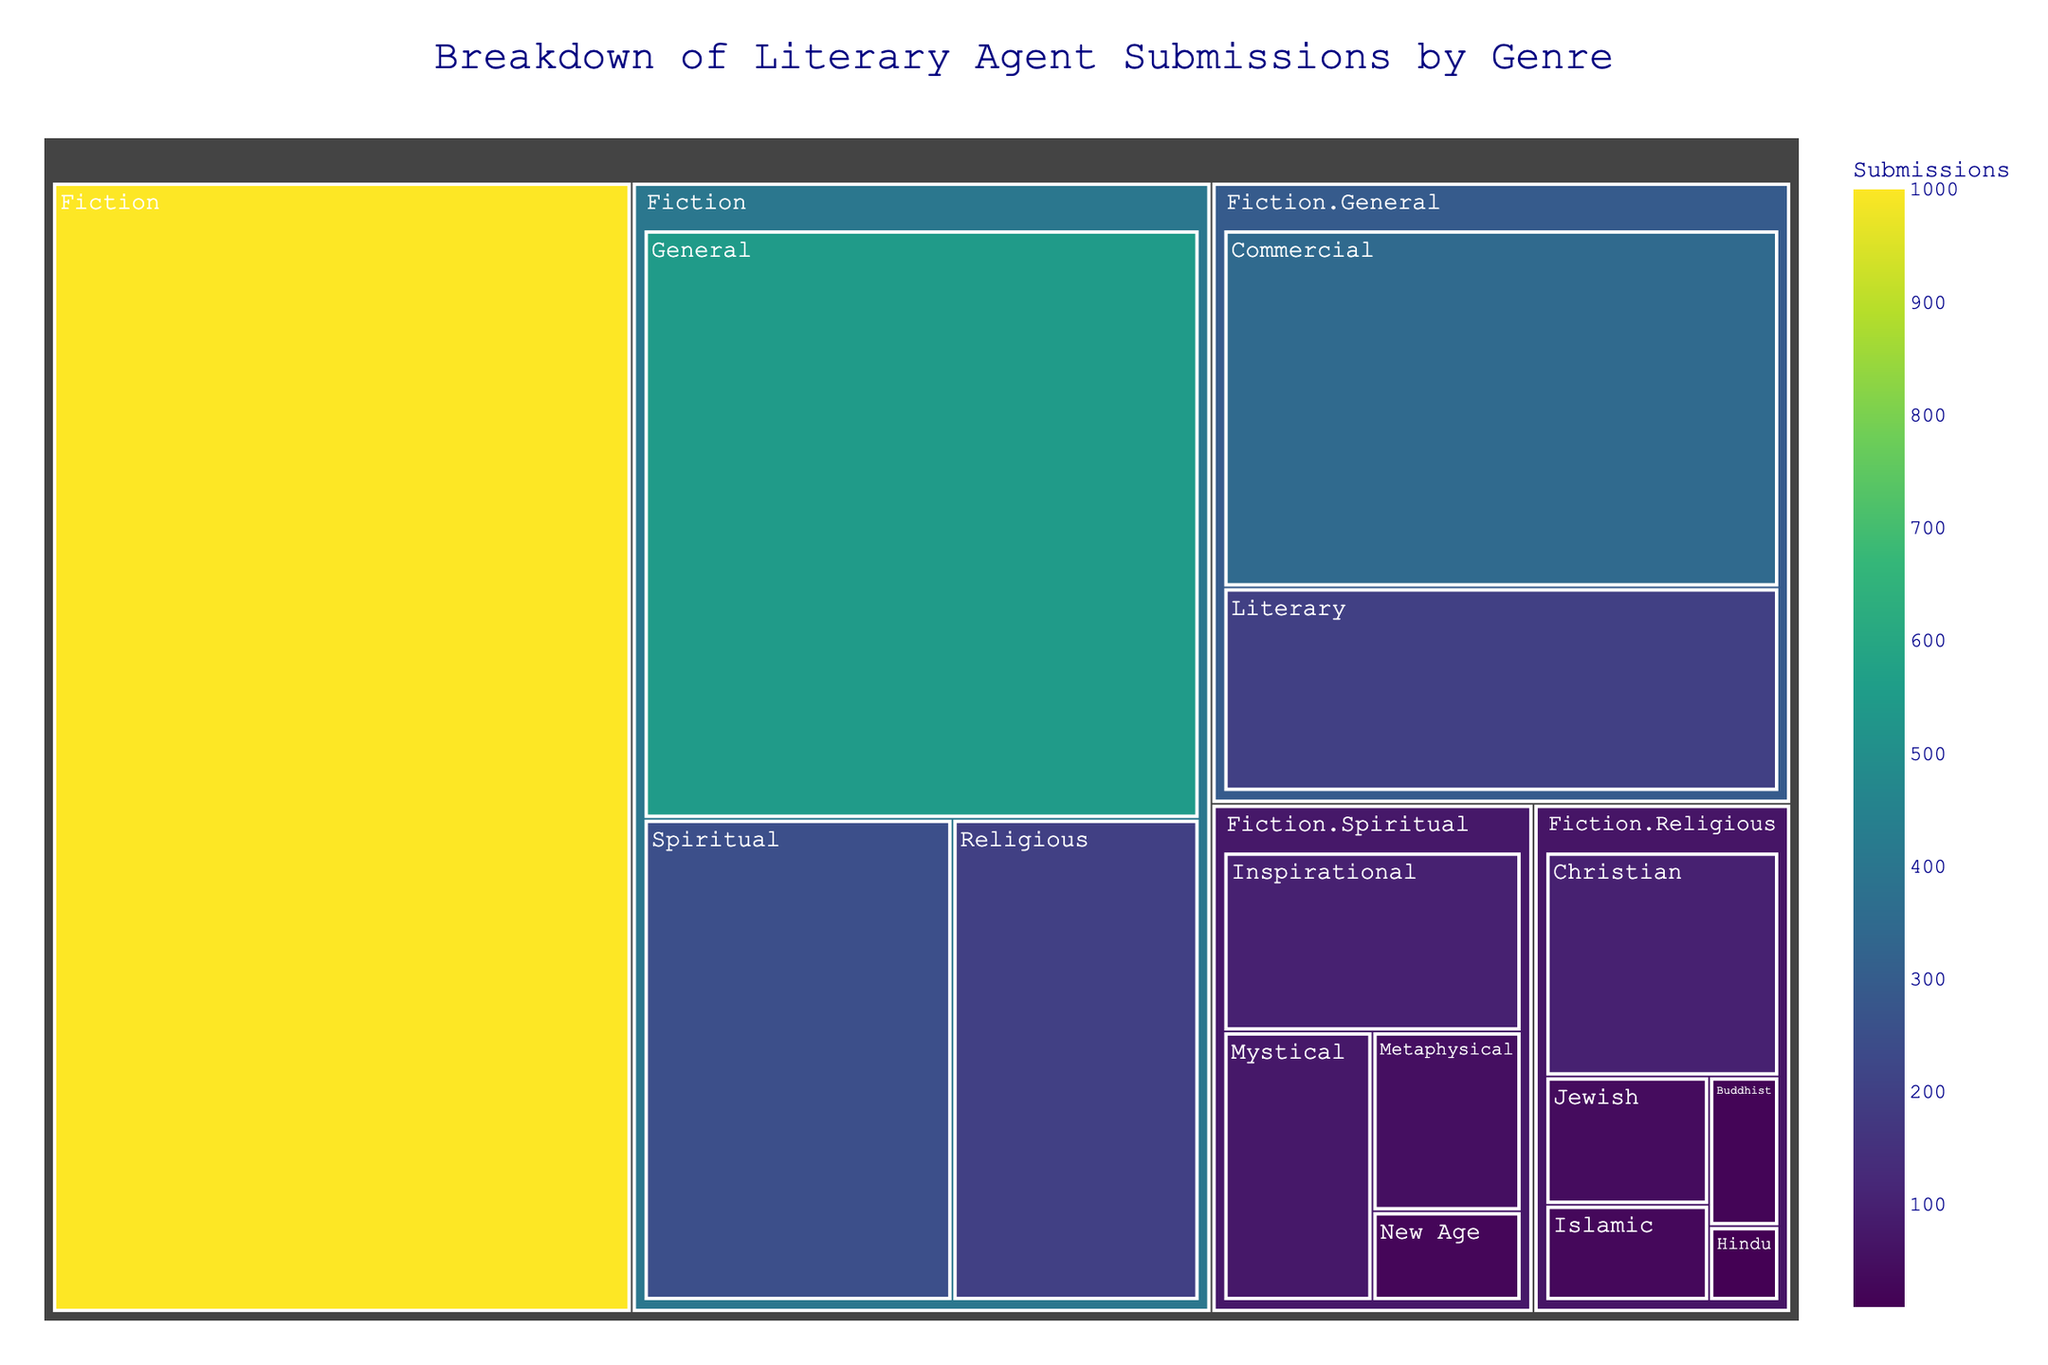What's the title of the figure? The title of the figure is typically found at the top, and in this case, it reads "Breakdown of Literary Agent Submissions by Genre."
Answer: Breakdown of Literary Agent Submissions by Genre Which sub-genre within "Fiction.Spiritual" has the highest number of submissions? Within the "Fiction.Spiritual" category, the sub-genres shown are "Mystical," "Inspirational," "Metaphysical," and "New Age." By looking at the values associated with each, "Inspirational" has the highest number of submissions (100).
Answer: Inspirational How many submissions fall under "Fiction.Religious"? "Fiction.Religious" has several sub-genres. The submissions for these sub-genres are 100 (Christian), 40 (Jewish), 30 (Islamic), 20 (Buddhist), and 10 (Hindu). Adding these values gives 100 + 40 + 30 + 20 + 10 = 200.
Answer: 200 What is the difference between the total submissions for "Fiction.Spiritual.Metaphysical" and "Fiction.Spiritual.New Age"? The number of submissions for "Fiction.Spiritual.Metaphysical" is 50, and for "Fiction.Spiritual.New Age" is 25. The difference is 50 - 25 = 25.
Answer: 25 Which genre has more submissions: "Fiction.Spiritual" or "Fiction.Religious"? "Fiction.Spiritual" has a total of 250 submissions, and "Fiction.Religious" has 200 submissions. Therefore, "Fiction.Spiritual" has more submissions.
Answer: Fiction.Spiritual What proportion of the total fiction submissions are from the "Spiritual" category? The total fiction submissions are 1000, with "Fiction.Spiritual" contributing 250. The proportion is calculated as (250/1000) * 100% = 25%.
Answer: 25% How do the submissions of "Fiction.Spiritual" compare to "Fiction.General"? "Fiction.Spiritual" has 250 submissions, whereas "Fiction.General" has 550 submissions. By comparison, "Fiction.General" has (550 - 250 = 300) more submissions than "Fiction.Spiritual."
Answer: Fiction.General has 300 more submissions Which sub-genre of "Fiction.Religious" has the lowest number of submissions? Within "Fiction.Religious," the sub-genres shown are "Christian," "Jewish," "Islamic," "Buddhist," and "Hindu." "Hindu" has the lowest number of submissions with 10 submissions.
Answer: Hindu 